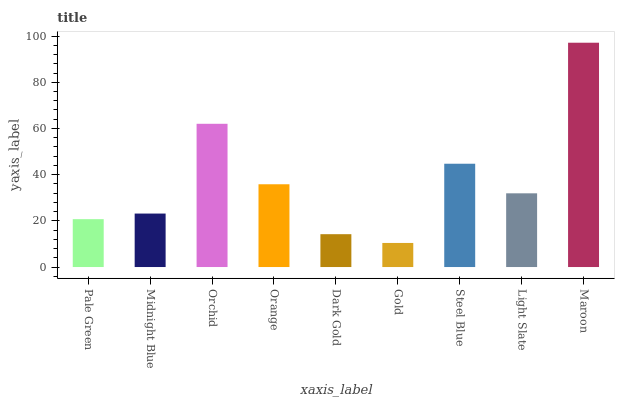Is Gold the minimum?
Answer yes or no. Yes. Is Maroon the maximum?
Answer yes or no. Yes. Is Midnight Blue the minimum?
Answer yes or no. No. Is Midnight Blue the maximum?
Answer yes or no. No. Is Midnight Blue greater than Pale Green?
Answer yes or no. Yes. Is Pale Green less than Midnight Blue?
Answer yes or no. Yes. Is Pale Green greater than Midnight Blue?
Answer yes or no. No. Is Midnight Blue less than Pale Green?
Answer yes or no. No. Is Light Slate the high median?
Answer yes or no. Yes. Is Light Slate the low median?
Answer yes or no. Yes. Is Orchid the high median?
Answer yes or no. No. Is Gold the low median?
Answer yes or no. No. 